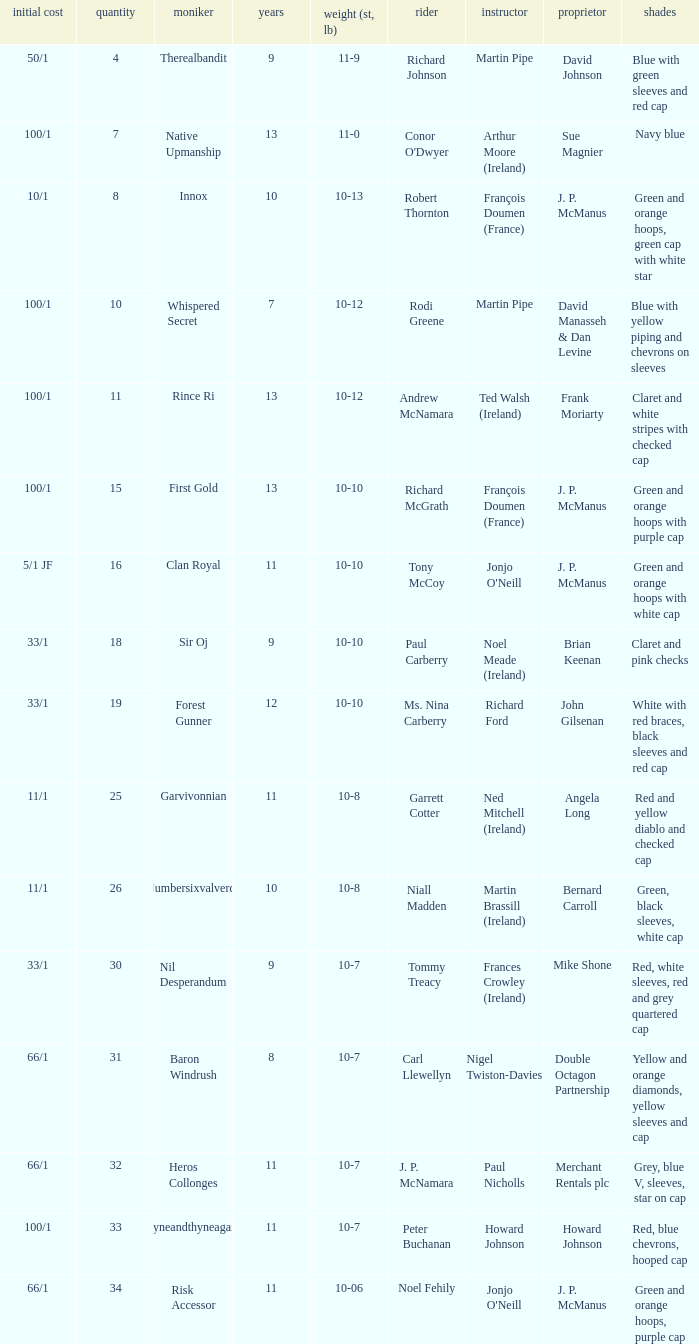What was the name that had a starting price of 11/1 and a jockey named Garrett Cotter? Garvivonnian. Could you parse the entire table? {'header': ['initial cost', 'quantity', 'moniker', 'years', 'weight (st, lb)', 'rider', 'instructor', 'proprietor', 'shades'], 'rows': [['50/1', '4', 'Therealbandit', '9', '11-9', 'Richard Johnson', 'Martin Pipe', 'David Johnson', 'Blue with green sleeves and red cap'], ['100/1', '7', 'Native Upmanship', '13', '11-0', "Conor O'Dwyer", 'Arthur Moore (Ireland)', 'Sue Magnier', 'Navy blue'], ['10/1', '8', 'Innox', '10', '10-13', 'Robert Thornton', 'François Doumen (France)', 'J. P. McManus', 'Green and orange hoops, green cap with white star'], ['100/1', '10', 'Whispered Secret', '7', '10-12', 'Rodi Greene', 'Martin Pipe', 'David Manasseh & Dan Levine', 'Blue with yellow piping and chevrons on sleeves'], ['100/1', '11', 'Rince Ri', '13', '10-12', 'Andrew McNamara', 'Ted Walsh (Ireland)', 'Frank Moriarty', 'Claret and white stripes with checked cap'], ['100/1', '15', 'First Gold', '13', '10-10', 'Richard McGrath', 'François Doumen (France)', 'J. P. McManus', 'Green and orange hoops with purple cap'], ['5/1 JF', '16', 'Clan Royal', '11', '10-10', 'Tony McCoy', "Jonjo O'Neill", 'J. P. McManus', 'Green and orange hoops with white cap'], ['33/1', '18', 'Sir Oj', '9', '10-10', 'Paul Carberry', 'Noel Meade (Ireland)', 'Brian Keenan', 'Claret and pink checks'], ['33/1', '19', 'Forest Gunner', '12', '10-10', 'Ms. Nina Carberry', 'Richard Ford', 'John Gilsenan', 'White with red braces, black sleeves and red cap'], ['11/1', '25', 'Garvivonnian', '11', '10-8', 'Garrett Cotter', 'Ned Mitchell (Ireland)', 'Angela Long', 'Red and yellow diablo and checked cap'], ['11/1', '26', 'Numbersixvalverde', '10', '10-8', 'Niall Madden', 'Martin Brassill (Ireland)', 'Bernard Carroll', 'Green, black sleeves, white cap'], ['33/1', '30', 'Nil Desperandum', '9', '10-7', 'Tommy Treacy', 'Frances Crowley (Ireland)', 'Mike Shone', 'Red, white sleeves, red and grey quartered cap'], ['66/1', '31', 'Baron Windrush', '8', '10-7', 'Carl Llewellyn', 'Nigel Twiston-Davies', 'Double Octagon Partnership', 'Yellow and orange diamonds, yellow sleeves and cap'], ['66/1', '32', 'Heros Collonges', '11', '10-7', 'J. P. McNamara', 'Paul Nicholls', 'Merchant Rentals plc', 'Grey, blue V, sleeves, star on cap'], ['100/1', '33', 'Tyneandthyneagain', '11', '10-7', 'Peter Buchanan', 'Howard Johnson', 'Howard Johnson', 'Red, blue chevrons, hooped cap'], ['66/1', '34', 'Risk Accessor', '11', '10-06', 'Noel Fehily', "Jonjo O'Neill", 'J. P. McManus', 'Green and orange hoops, purple cap']]} 